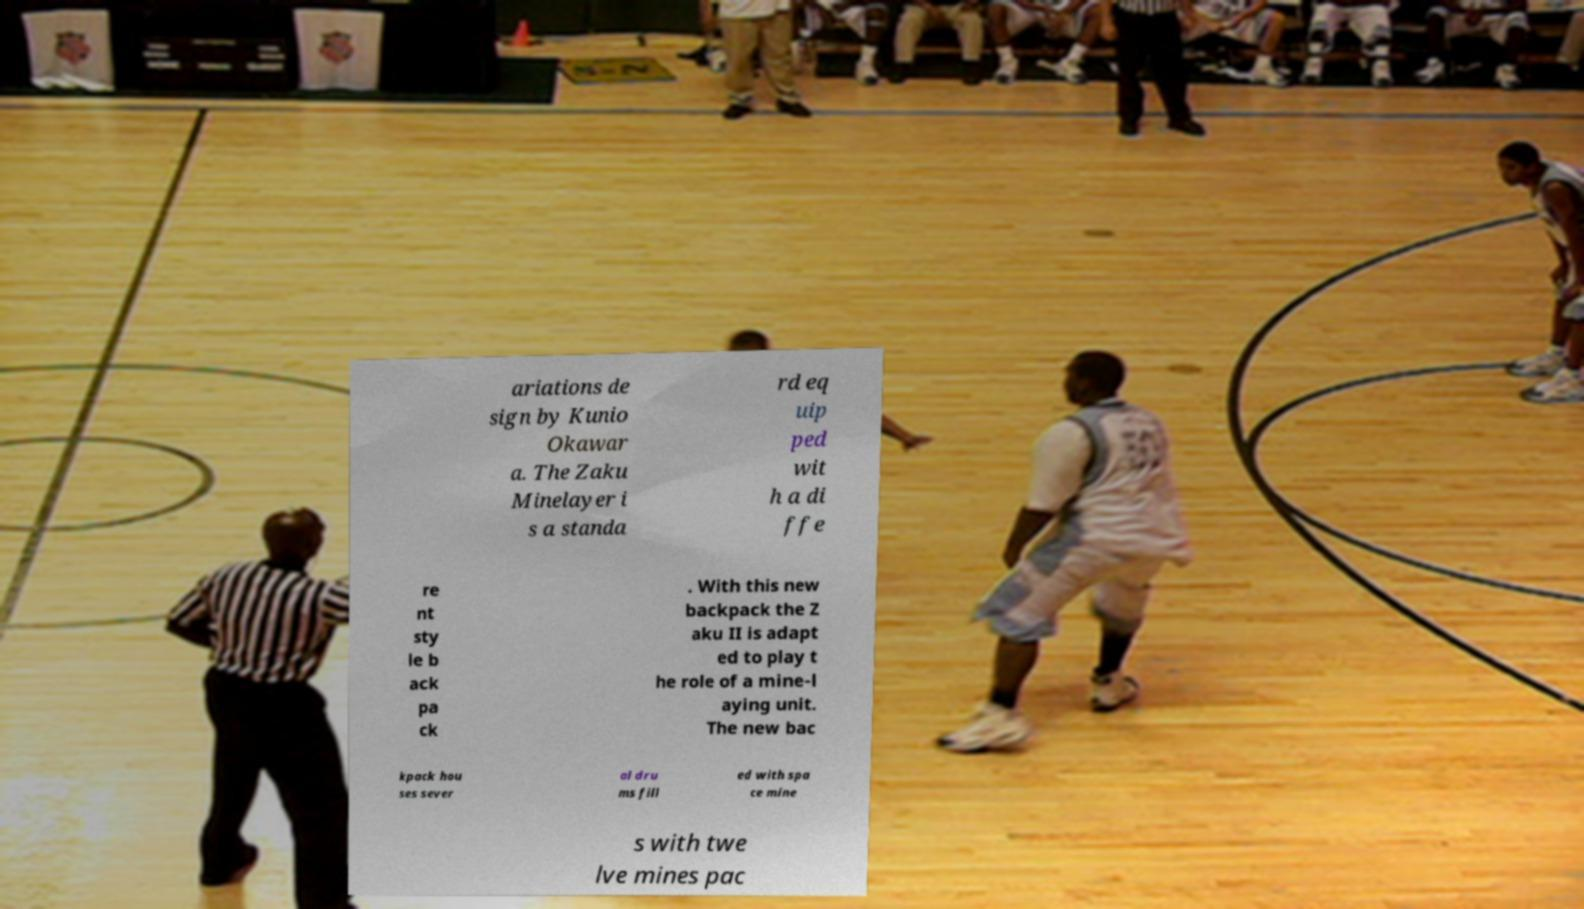Could you extract and type out the text from this image? ariations de sign by Kunio Okawar a. The Zaku Minelayer i s a standa rd eq uip ped wit h a di ffe re nt sty le b ack pa ck . With this new backpack the Z aku II is adapt ed to play t he role of a mine-l aying unit. The new bac kpack hou ses sever al dru ms fill ed with spa ce mine s with twe lve mines pac 